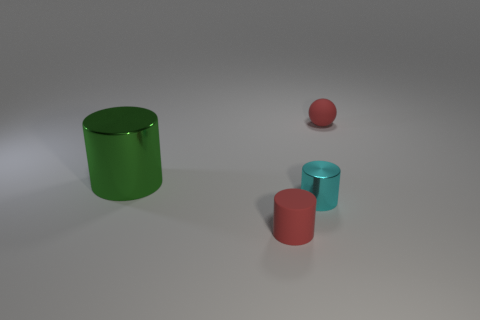Do the ball and the large metal object have the same color?
Offer a very short reply. No. What number of objects are small objects in front of the cyan metal thing or cylinders?
Your answer should be compact. 3. There is a tiny matte thing to the left of the tiny red ball; what number of red cylinders are in front of it?
Your answer should be compact. 0. What is the size of the cylinder to the right of the red thing that is in front of the red rubber object behind the green shiny thing?
Your answer should be compact. Small. Do the tiny thing that is behind the green cylinder and the small matte cylinder have the same color?
Your response must be concise. Yes. There is another matte object that is the same shape as the cyan object; what size is it?
Keep it short and to the point. Small. What number of objects are large shiny cylinders that are left of the tiny sphere or things that are in front of the large green cylinder?
Your answer should be very brief. 3. The tiny red matte thing that is to the right of the small cylinder that is in front of the tiny cyan cylinder is what shape?
Ensure brevity in your answer.  Sphere. Are there any other things that have the same color as the tiny ball?
Provide a succinct answer. Yes. Is there any other thing that is the same size as the red cylinder?
Give a very brief answer. Yes. 